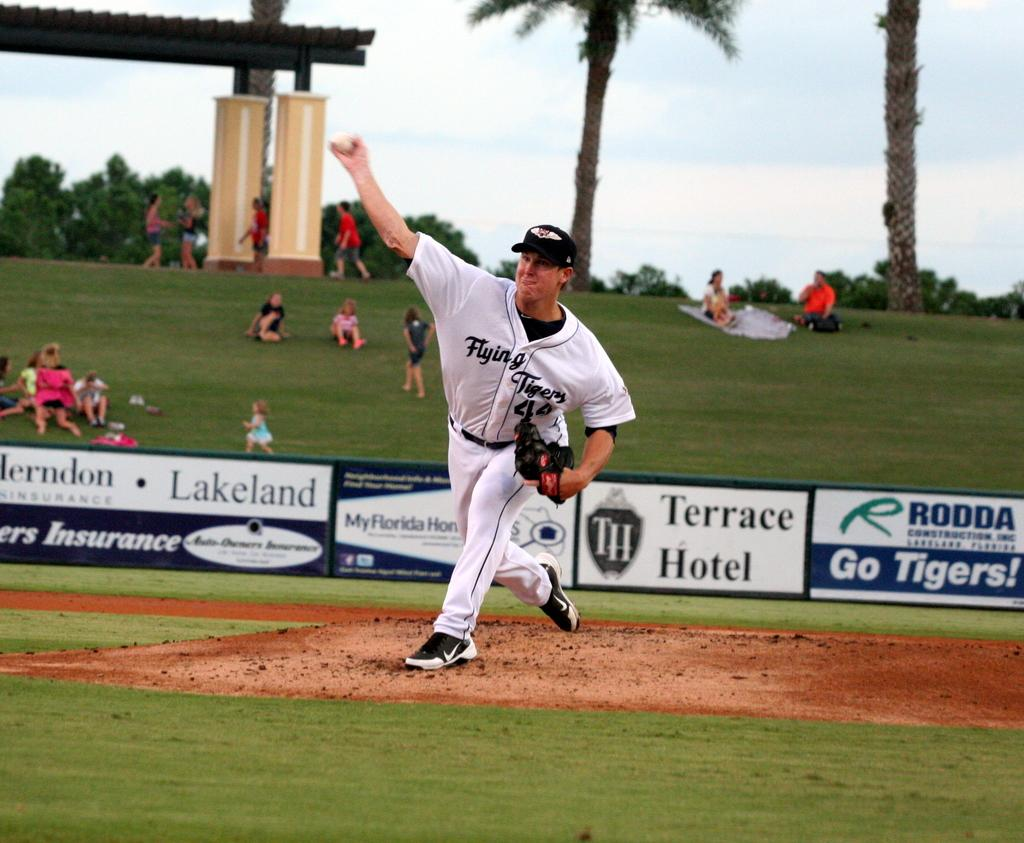<image>
Summarize the visual content of the image. A team member of the Flying Tigers baseball team on the field with people watching in the background. 